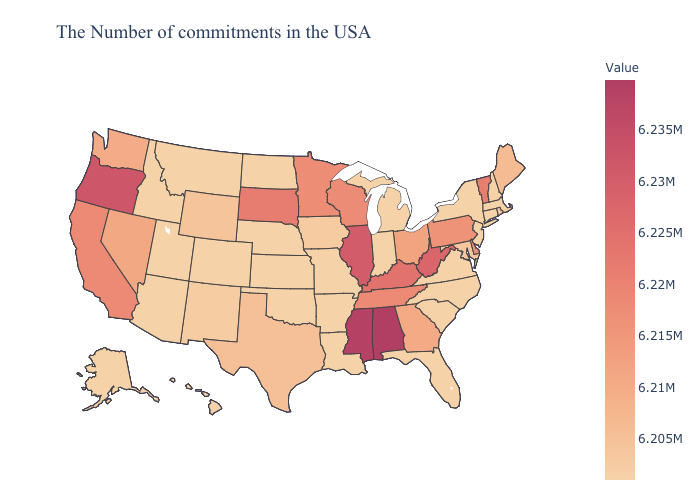Among the states that border Louisiana , which have the highest value?
Concise answer only. Mississippi. Does the map have missing data?
Give a very brief answer. No. 